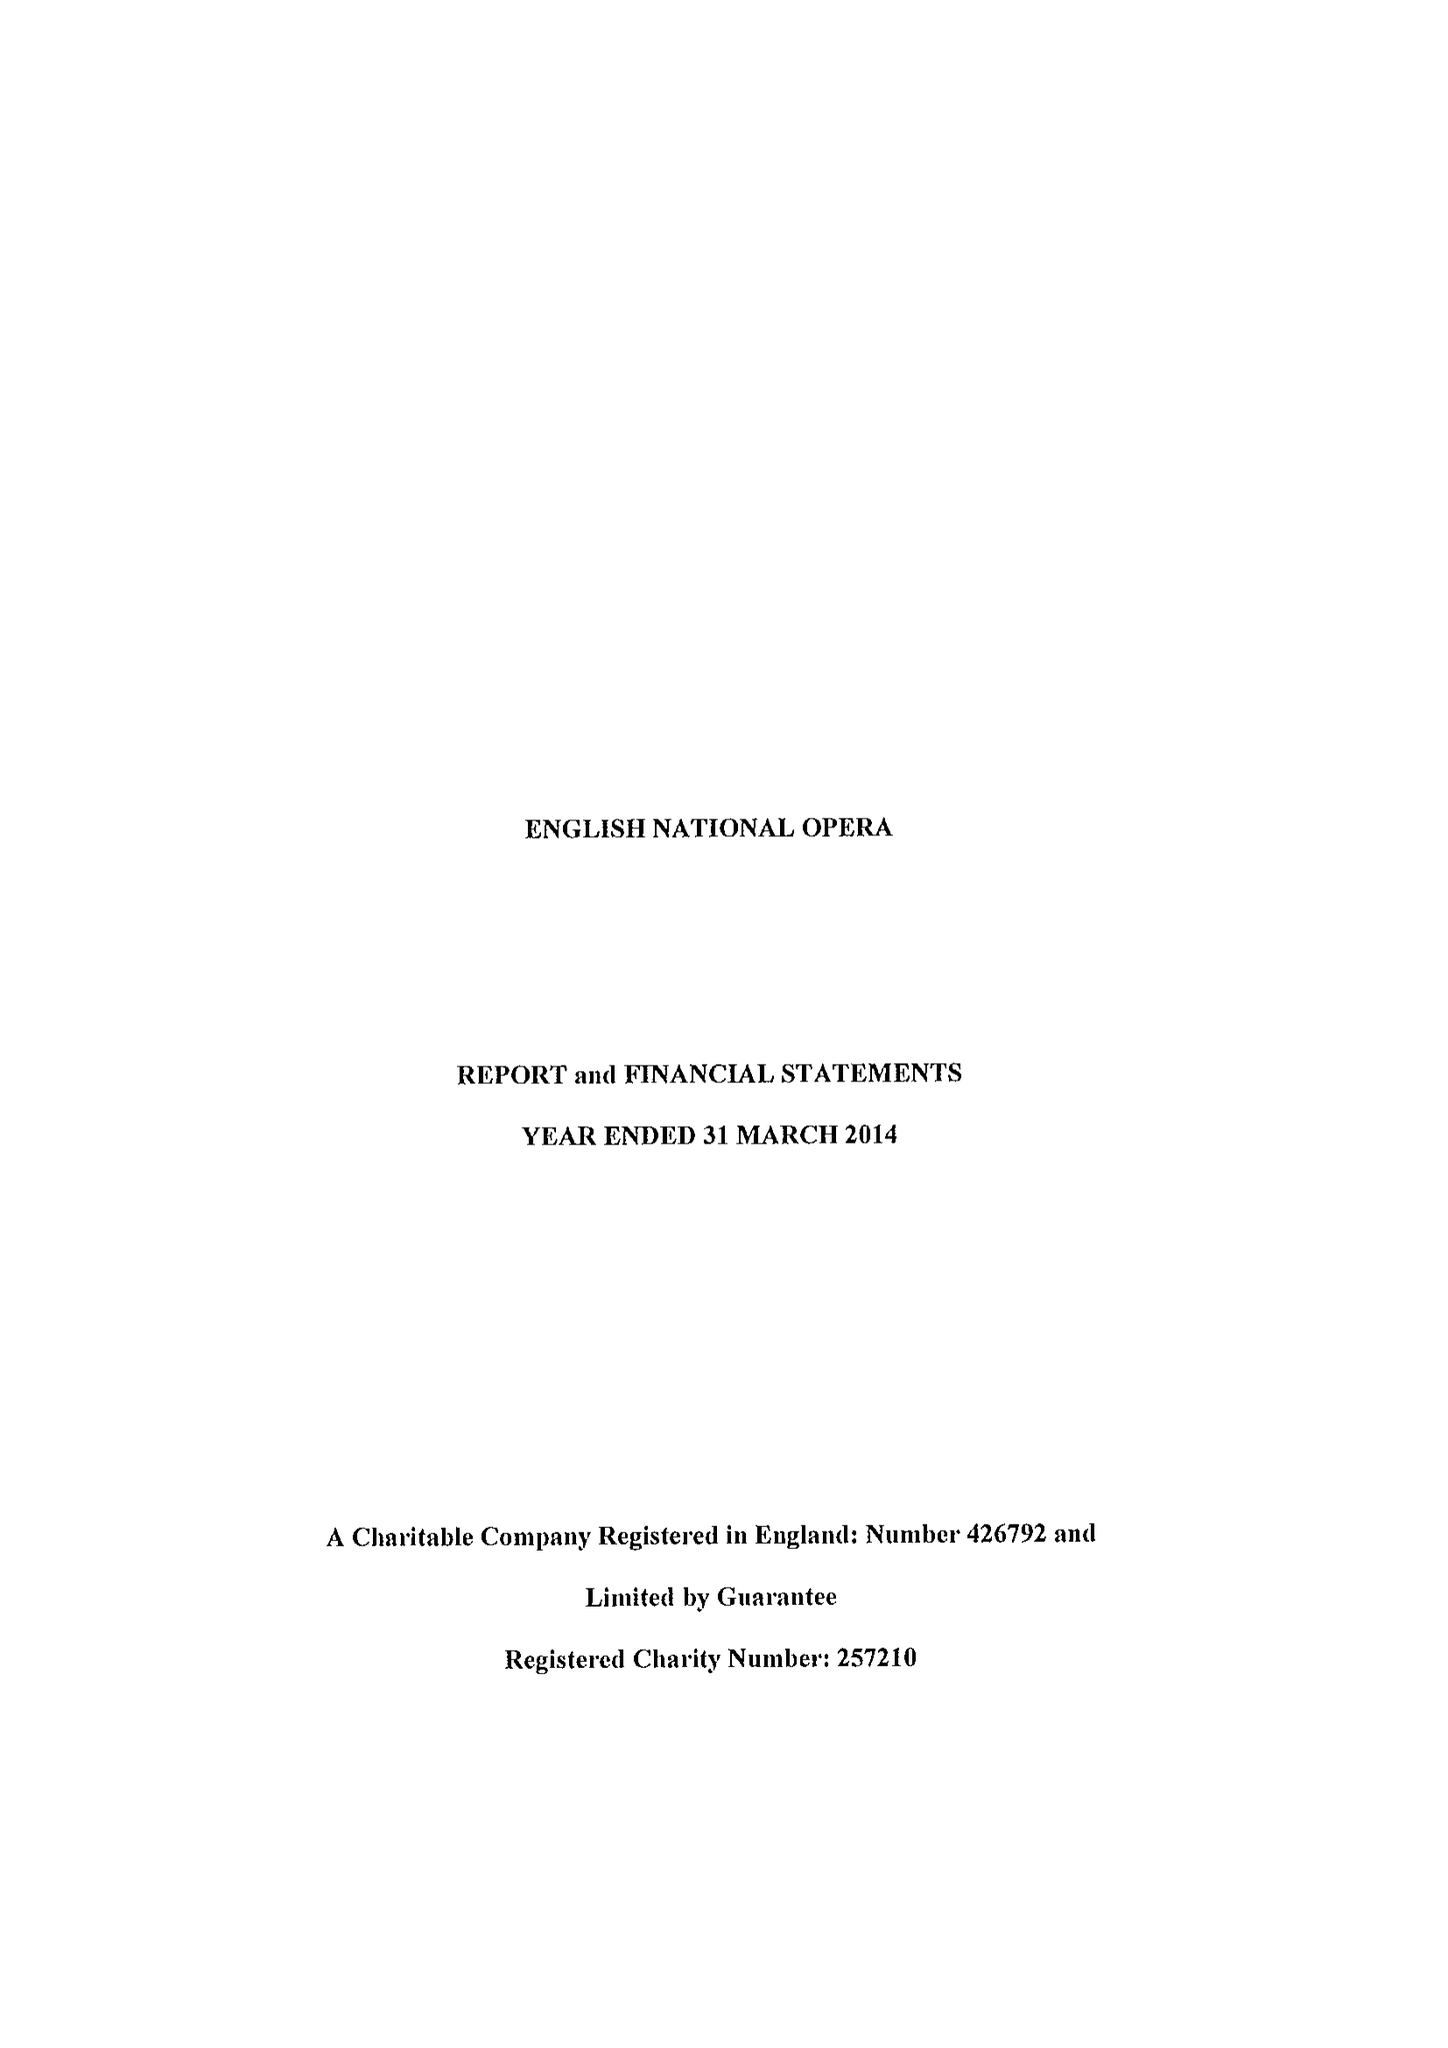What is the value for the charity_name?
Answer the question using a single word or phrase. English National Opera Ltd. 